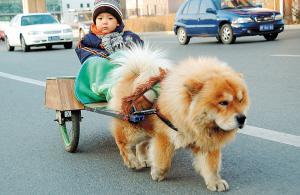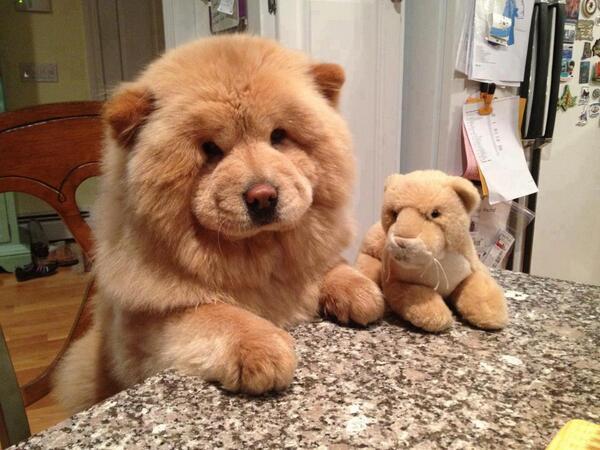The first image is the image on the left, the second image is the image on the right. For the images displayed, is the sentence "There are at least four dogs." factually correct? Answer yes or no. No. 